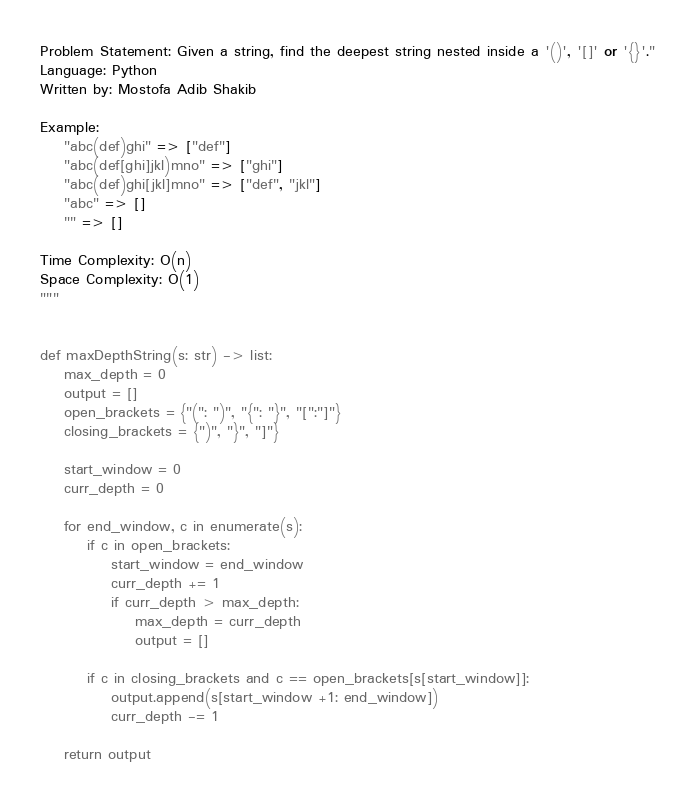Convert code to text. <code><loc_0><loc_0><loc_500><loc_500><_Python_>Problem Statement: Given a string, find the deepest string nested inside a '()', '[]' or '{}'."
Language: Python
Written by: Mostofa Adib Shakib

Example: 
    "abc(def)ghi" => ["def"]
    "abc(def[ghi]jkl)mno" => ["ghi"]
    "abc(def)ghi[jkl]mno" => ["def", "jkl"]
    "abc" => []
    "" => []

Time Complexity: O(n)
Space Complexity: O(1)
"""


def maxDepthString(s: str) -> list:
    max_depth = 0
    output = []
    open_brackets = {"(": ")", "{": "}", "[":"]"}
    closing_brackets = {")", "}", "]"}
    
    start_window = 0
    curr_depth = 0
    
    for end_window, c in enumerate(s):
        if c in open_brackets:
            start_window = end_window
            curr_depth += 1
            if curr_depth > max_depth:
                max_depth = curr_depth
                output = []
            
        if c in closing_brackets and c == open_brackets[s[start_window]]:
            output.append(s[start_window +1: end_window])
            curr_depth -= 1
            
    return output</code> 